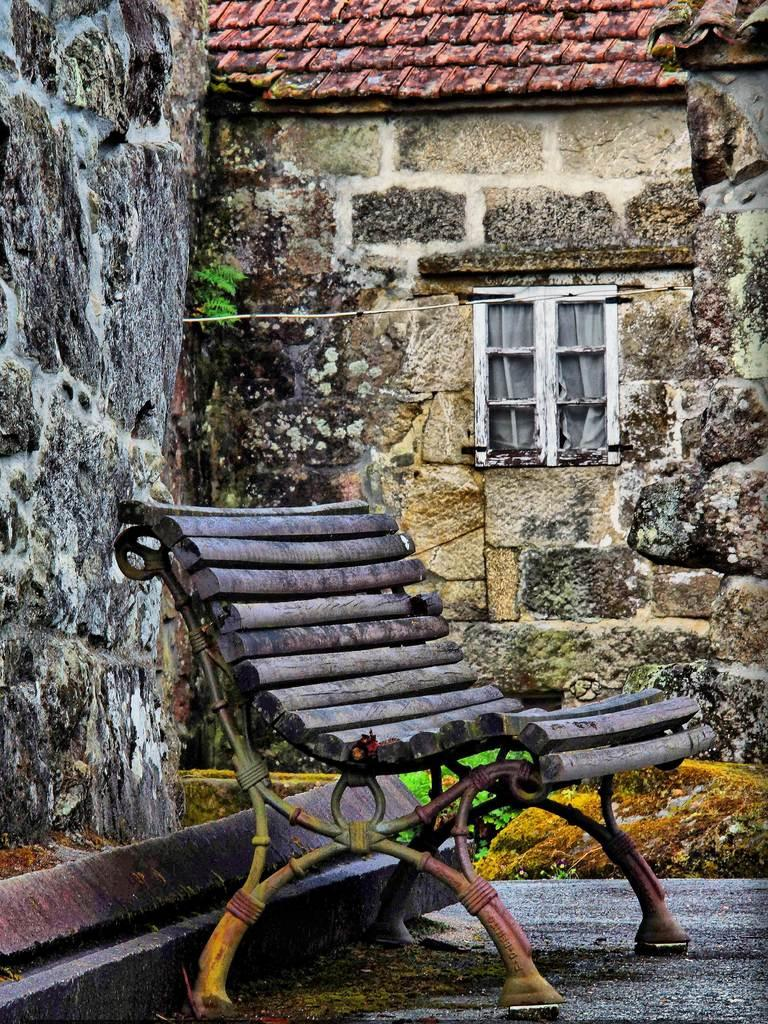What type of furniture is present in the image? There is a bench in the image. On what surface is the bench placed? The bench is on a surface. What can be seen in the background of the image? There is a wall, a roof top, and a window visible in the background of the image. Where is the rabbit hiding in the image? There is no rabbit present in the image. What type of rod can be seen supporting the roof top in the image? There is no specific rod visible in the image; only the roof top is mentioned. 